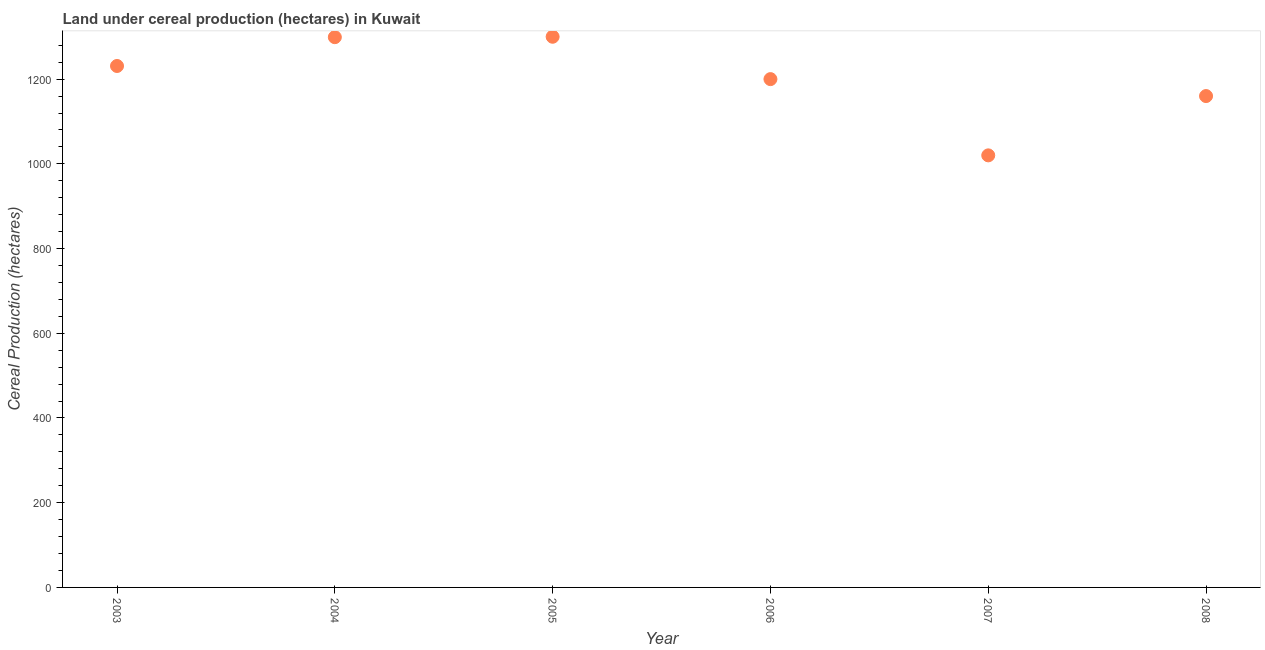What is the land under cereal production in 2007?
Your answer should be very brief. 1020. Across all years, what is the maximum land under cereal production?
Your response must be concise. 1300. Across all years, what is the minimum land under cereal production?
Offer a terse response. 1020. In which year was the land under cereal production maximum?
Your response must be concise. 2005. What is the sum of the land under cereal production?
Ensure brevity in your answer.  7210. What is the difference between the land under cereal production in 2003 and 2006?
Your answer should be compact. 31. What is the average land under cereal production per year?
Give a very brief answer. 1201.67. What is the median land under cereal production?
Give a very brief answer. 1215.5. In how many years, is the land under cereal production greater than 160 hectares?
Provide a succinct answer. 6. What is the ratio of the land under cereal production in 2004 to that in 2006?
Offer a terse response. 1.08. What is the difference between the highest and the second highest land under cereal production?
Ensure brevity in your answer.  1. What is the difference between the highest and the lowest land under cereal production?
Make the answer very short. 280. Does the land under cereal production monotonically increase over the years?
Ensure brevity in your answer.  No. How many years are there in the graph?
Ensure brevity in your answer.  6. What is the title of the graph?
Keep it short and to the point. Land under cereal production (hectares) in Kuwait. What is the label or title of the X-axis?
Give a very brief answer. Year. What is the label or title of the Y-axis?
Offer a very short reply. Cereal Production (hectares). What is the Cereal Production (hectares) in 2003?
Give a very brief answer. 1231. What is the Cereal Production (hectares) in 2004?
Your response must be concise. 1299. What is the Cereal Production (hectares) in 2005?
Provide a short and direct response. 1300. What is the Cereal Production (hectares) in 2006?
Your response must be concise. 1200. What is the Cereal Production (hectares) in 2007?
Your answer should be compact. 1020. What is the Cereal Production (hectares) in 2008?
Your answer should be compact. 1160. What is the difference between the Cereal Production (hectares) in 2003 and 2004?
Make the answer very short. -68. What is the difference between the Cereal Production (hectares) in 2003 and 2005?
Ensure brevity in your answer.  -69. What is the difference between the Cereal Production (hectares) in 2003 and 2007?
Ensure brevity in your answer.  211. What is the difference between the Cereal Production (hectares) in 2003 and 2008?
Give a very brief answer. 71. What is the difference between the Cereal Production (hectares) in 2004 and 2005?
Your response must be concise. -1. What is the difference between the Cereal Production (hectares) in 2004 and 2007?
Offer a very short reply. 279. What is the difference between the Cereal Production (hectares) in 2004 and 2008?
Offer a terse response. 139. What is the difference between the Cereal Production (hectares) in 2005 and 2007?
Offer a terse response. 280. What is the difference between the Cereal Production (hectares) in 2005 and 2008?
Offer a very short reply. 140. What is the difference between the Cereal Production (hectares) in 2006 and 2007?
Make the answer very short. 180. What is the difference between the Cereal Production (hectares) in 2006 and 2008?
Provide a succinct answer. 40. What is the difference between the Cereal Production (hectares) in 2007 and 2008?
Your response must be concise. -140. What is the ratio of the Cereal Production (hectares) in 2003 to that in 2004?
Provide a short and direct response. 0.95. What is the ratio of the Cereal Production (hectares) in 2003 to that in 2005?
Make the answer very short. 0.95. What is the ratio of the Cereal Production (hectares) in 2003 to that in 2006?
Provide a short and direct response. 1.03. What is the ratio of the Cereal Production (hectares) in 2003 to that in 2007?
Offer a very short reply. 1.21. What is the ratio of the Cereal Production (hectares) in 2003 to that in 2008?
Offer a terse response. 1.06. What is the ratio of the Cereal Production (hectares) in 2004 to that in 2006?
Offer a very short reply. 1.08. What is the ratio of the Cereal Production (hectares) in 2004 to that in 2007?
Provide a succinct answer. 1.27. What is the ratio of the Cereal Production (hectares) in 2004 to that in 2008?
Offer a terse response. 1.12. What is the ratio of the Cereal Production (hectares) in 2005 to that in 2006?
Offer a very short reply. 1.08. What is the ratio of the Cereal Production (hectares) in 2005 to that in 2007?
Offer a terse response. 1.27. What is the ratio of the Cereal Production (hectares) in 2005 to that in 2008?
Ensure brevity in your answer.  1.12. What is the ratio of the Cereal Production (hectares) in 2006 to that in 2007?
Your answer should be very brief. 1.18. What is the ratio of the Cereal Production (hectares) in 2006 to that in 2008?
Provide a succinct answer. 1.03. What is the ratio of the Cereal Production (hectares) in 2007 to that in 2008?
Give a very brief answer. 0.88. 